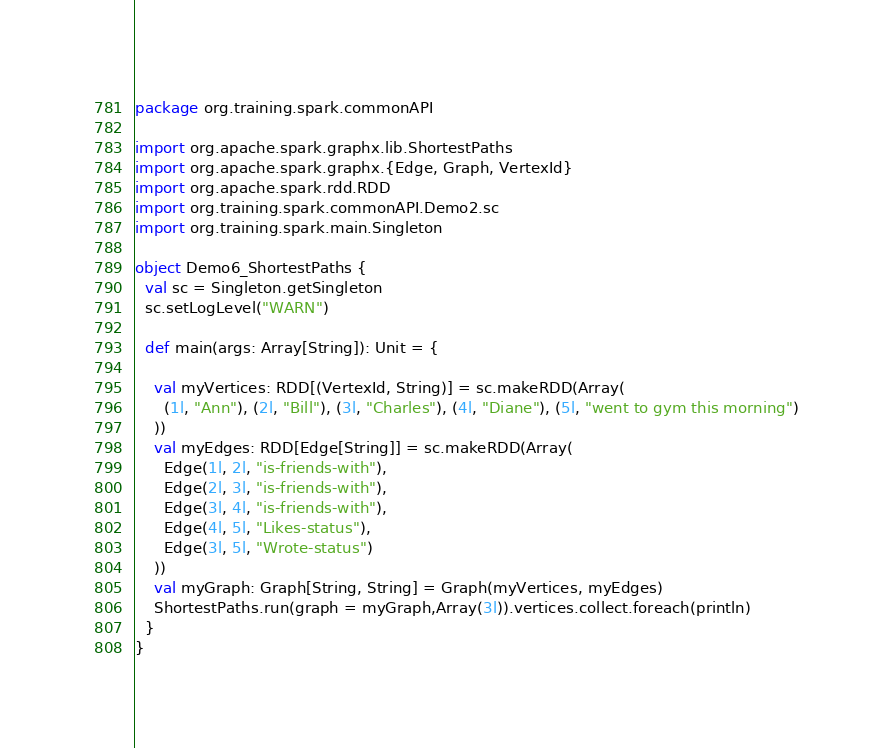<code> <loc_0><loc_0><loc_500><loc_500><_Scala_>package org.training.spark.commonAPI

import org.apache.spark.graphx.lib.ShortestPaths
import org.apache.spark.graphx.{Edge, Graph, VertexId}
import org.apache.spark.rdd.RDD
import org.training.spark.commonAPI.Demo2.sc
import org.training.spark.main.Singleton

object Demo6_ShortestPaths {
  val sc = Singleton.getSingleton
  sc.setLogLevel("WARN")

  def main(args: Array[String]): Unit = {

    val myVertices: RDD[(VertexId, String)] = sc.makeRDD(Array(
      (1l, "Ann"), (2l, "Bill"), (3l, "Charles"), (4l, "Diane"), (5l, "went to gym this morning")
    ))
    val myEdges: RDD[Edge[String]] = sc.makeRDD(Array(
      Edge(1l, 2l, "is-friends-with"),
      Edge(2l, 3l, "is-friends-with"),
      Edge(3l, 4l, "is-friends-with"),
      Edge(4l, 5l, "Likes-status"),
      Edge(3l, 5l, "Wrote-status")
    ))
    val myGraph: Graph[String, String] = Graph(myVertices, myEdges)
    ShortestPaths.run(graph = myGraph,Array(3l)).vertices.collect.foreach(println)
  }
}
</code> 